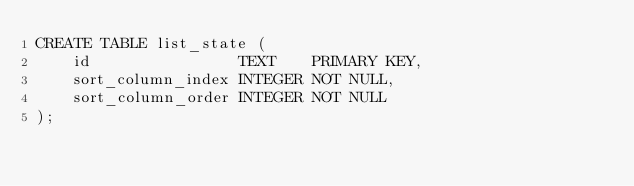<code> <loc_0><loc_0><loc_500><loc_500><_SQL_>CREATE TABLE list_state (
    id                TEXT    PRIMARY KEY,
    sort_column_index INTEGER NOT NULL,
    sort_column_order INTEGER NOT NULL
);
</code> 